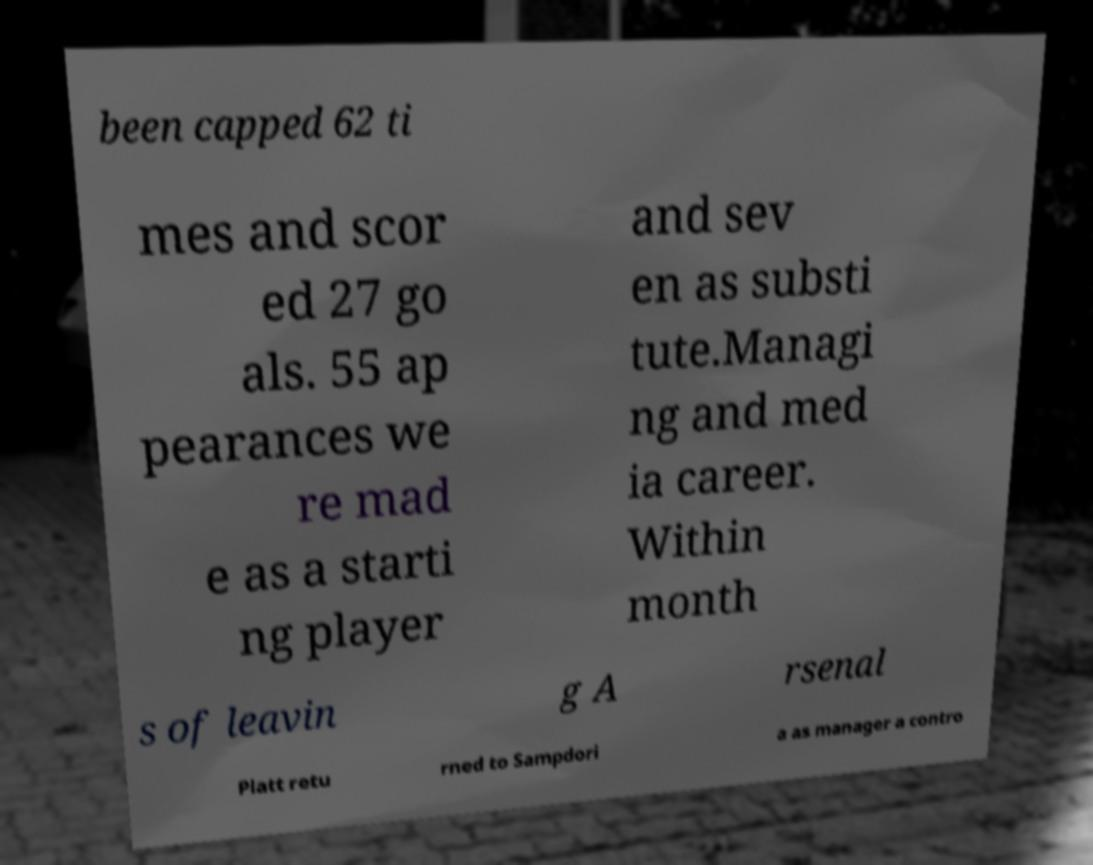Could you extract and type out the text from this image? been capped 62 ti mes and scor ed 27 go als. 55 ap pearances we re mad e as a starti ng player and sev en as substi tute.Managi ng and med ia career. Within month s of leavin g A rsenal Platt retu rned to Sampdori a as manager a contro 